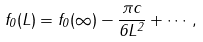<formula> <loc_0><loc_0><loc_500><loc_500>f _ { 0 } ( L ) = f _ { 0 } ( \infty ) - \frac { \pi c } { 6 L ^ { 2 } } + \cdots \, ,</formula> 